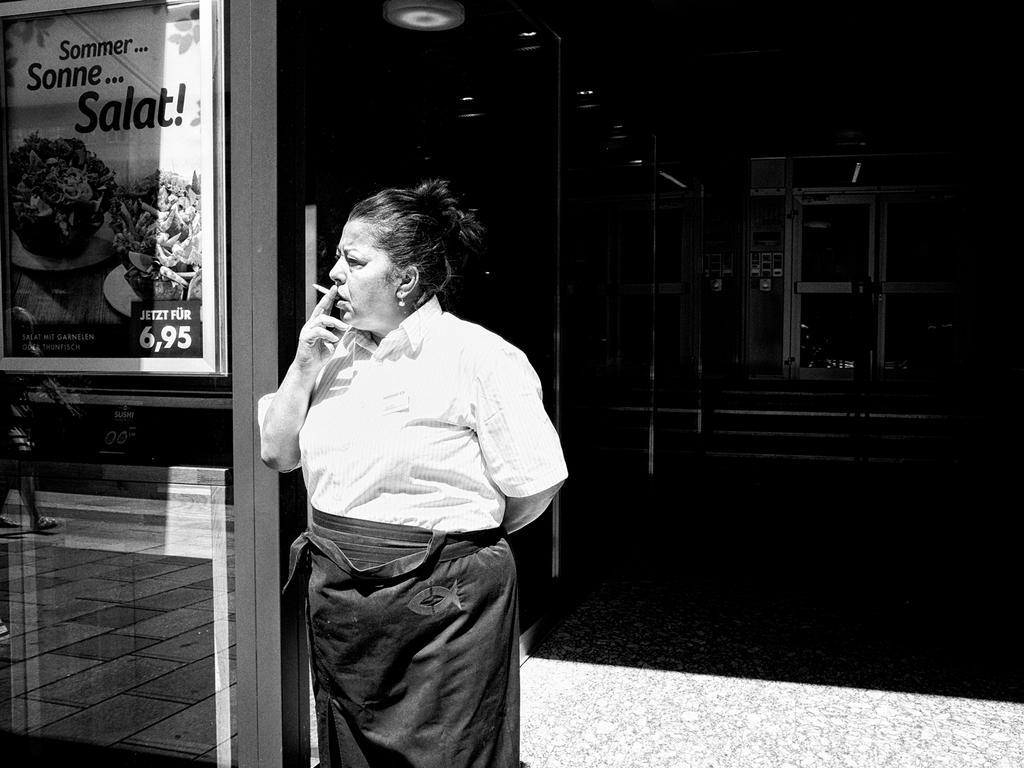Please provide a concise description of this image. In this image we can see a person holding a cigarette, there is a board with text and images on the glass beside the person and there is a building and stairs in the background. 